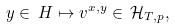<formula> <loc_0><loc_0><loc_500><loc_500>y \in \, H \mapsto v ^ { x , y } \in \, \mathcal { H } _ { T , p } ,</formula> 